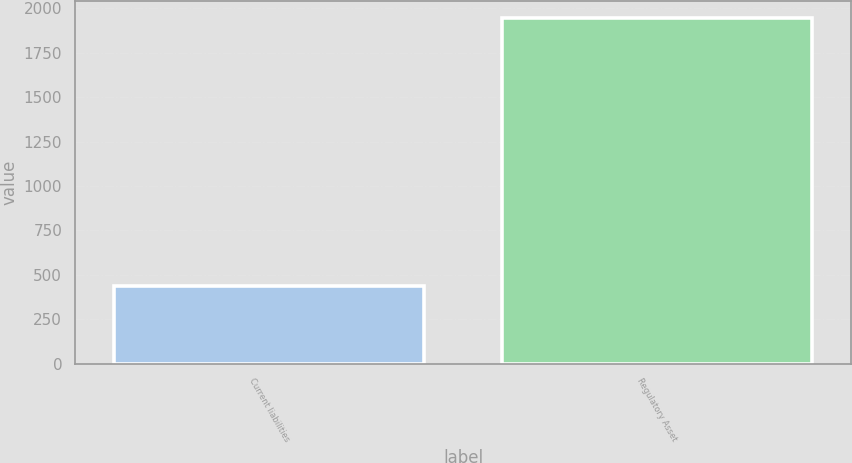<chart> <loc_0><loc_0><loc_500><loc_500><bar_chart><fcel>Current liabilities<fcel>Regulatory Asset<nl><fcel>439<fcel>1946<nl></chart> 